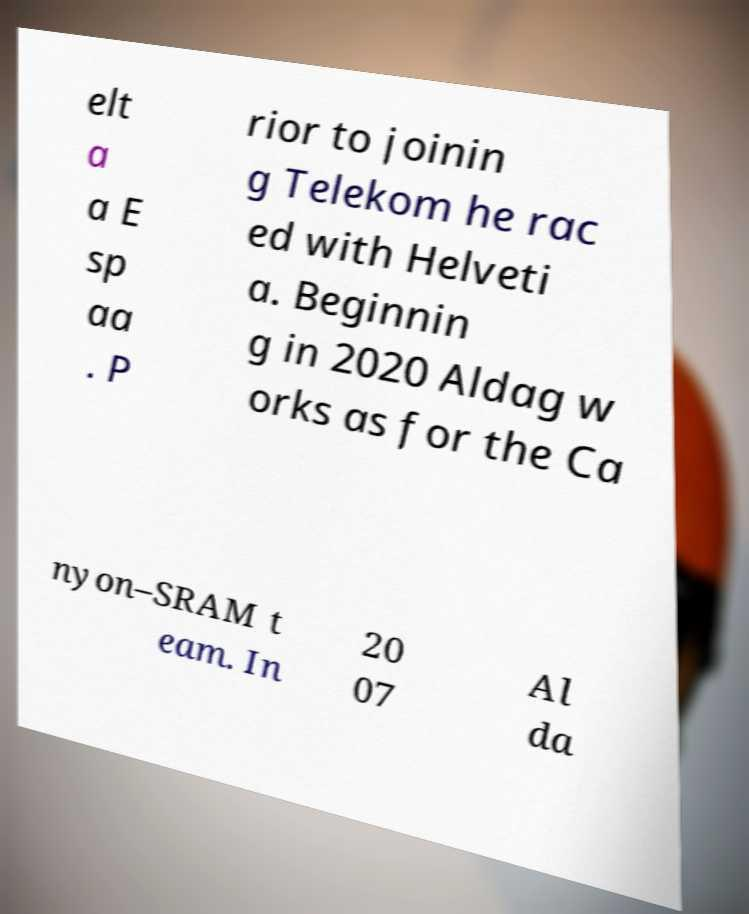What messages or text are displayed in this image? I need them in a readable, typed format. elt a a E sp aa . P rior to joinin g Telekom he rac ed with Helveti a. Beginnin g in 2020 Aldag w orks as for the Ca nyon–SRAM t eam. In 20 07 Al da 